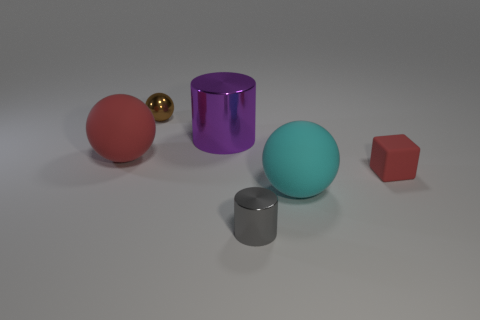Subtract all blue spheres. Subtract all purple cylinders. How many spheres are left? 3 Add 3 cyan things. How many objects exist? 9 Subtract all blocks. How many objects are left? 5 Add 2 tiny yellow metal blocks. How many tiny yellow metal blocks exist? 2 Subtract 0 brown cylinders. How many objects are left? 6 Subtract all brown metal balls. Subtract all big shiny cylinders. How many objects are left? 4 Add 3 cubes. How many cubes are left? 4 